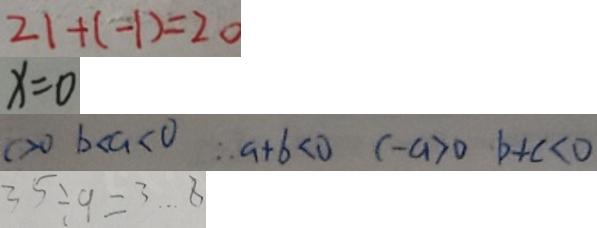Convert formula to latex. <formula><loc_0><loc_0><loc_500><loc_500>2 1 + ( - 1 ) = 2 0 
 x = 0 
 c > 0 b < a < 0 \therefore a + b < 0 c - a > 0 b + c < 0 
 3 5 \div 9 = 3 \cdots 8</formula> 